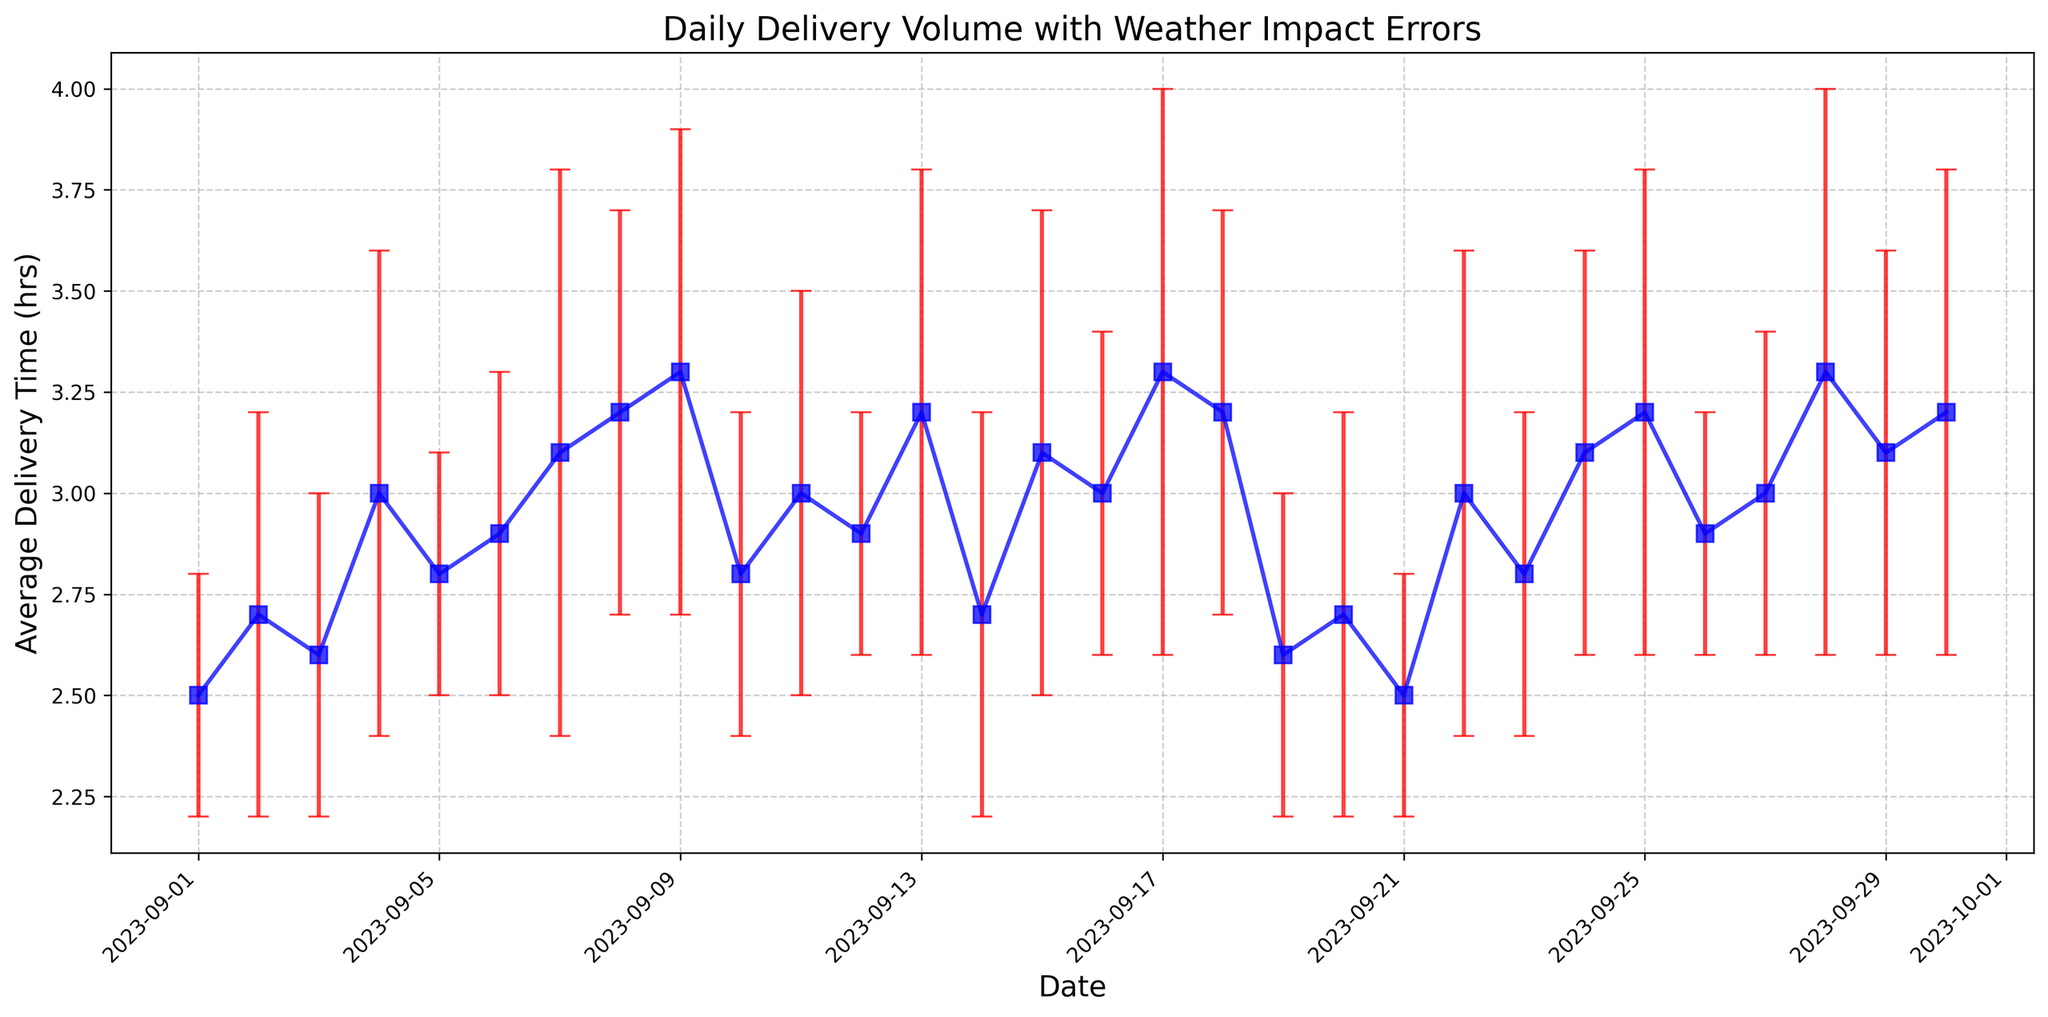What's the day with the highest average delivery time? To find the day with the highest average delivery time, look at the point with the highest y-value on the plot. The highest point corresponds to September 28 and 17, where the average delivery time is 3.3 hours.
Answer: September 28 and 17 Which date has the lowest weather impact error? The weather impact errors are represented by the length of the error bars. The shortest error bar corresponds to the lowest weather impact error, which occurs on September 1, 5, 12, and 26 with an error of 0.3 hours.
Answer: September 1, 5, 12, and 26 Compare the average delivery times on September 1 and September 29. Which date has a lower average delivery time? September 1 has an average delivery time of 2.5 hours and September 29 has an average delivery time of 3.1 hours. Since 2.5 is less than 3.1, September 1 has a lower average delivery time.
Answer: September 1 What is the range of average delivery times in September? The range is calculated by subtracting the smallest average delivery time from the largest. The smallest average delivery time is 2.5 hours (September 1) and the largest is 3.3 hours (September 17, 28). Therefore, the range is 3.3 - 2.5 = 0.8 hours.
Answer: 0.8 hours How do the average delivery times and weather impact errors on September 4 and September 20 compare? On September 4, the average delivery time is 3.0 hours with an error of 0.6 hours, and on September 20, it is 2.7 hours with an error of 0.5 hours. Therefore, September 4 has a higher average delivery time and a slightly higher weather impact error than September 20.
Answer: September 4 has higher values What is the median average delivery time in September? To calculate the median, list all average delivery times in ascending order and find the middle value. With 30 days, the median value is the average of the 15th and 16th values in the sorted list. These values are 3.0 and 3.0, so the median is (3.0 + 3.0)/2 = 3.0 hours.
Answer: 3.0 hours On which days did the average delivery time match the overall median average delivery time? The overall median average delivery time is 3.0 hours. The days with an average delivery time of 3.0 hours are September 4, 11, 16, 22, and 27.
Answer: September 4, 11, 16, 22, 27 Which date has the most significant weather impact error among those with the same average delivery time of 3.2 hours? The dates with an average delivery time of 3.2 hours are September 8, 18, 25, and 30. Among these, the biggest weather impact error is on September 30, with an error of 0.6 hours.
Answer: September 30 What is the average of the weather impact errors? To find the average, sum all the weather impact errors and divide by the number of days. Sum of errors = 0.3+0.5+0.4+0.6+0.3+0.4+0.7+0.5+0.6+0.4+0.5+0.3+0.6+0.5+0.6+0.4+0.7+0.5+0.4+0.5+0.3+0.6+0.4+0.5+0.6+0.3+0.4+0.7+0.5+0.6 = 15.0 hours. There are 30 days, so the average error is 15.0/30 = 0.5 hours.
Answer: 0.5 hours Which day in the second half of September had the highest average delivery time? Look for the highest average delivery time in the second half of the month (September 16-30). The highest average delivery time is on September 28, where the average delivery time is 3.3 hours.
Answer: September 28 